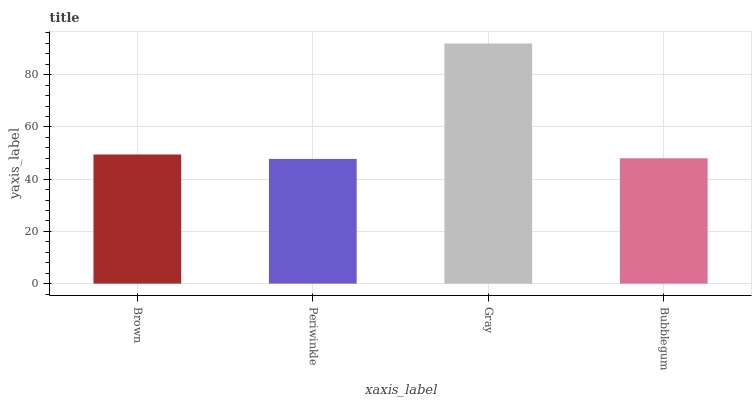Is Gray the minimum?
Answer yes or no. No. Is Periwinkle the maximum?
Answer yes or no. No. Is Gray greater than Periwinkle?
Answer yes or no. Yes. Is Periwinkle less than Gray?
Answer yes or no. Yes. Is Periwinkle greater than Gray?
Answer yes or no. No. Is Gray less than Periwinkle?
Answer yes or no. No. Is Brown the high median?
Answer yes or no. Yes. Is Bubblegum the low median?
Answer yes or no. Yes. Is Periwinkle the high median?
Answer yes or no. No. Is Gray the low median?
Answer yes or no. No. 